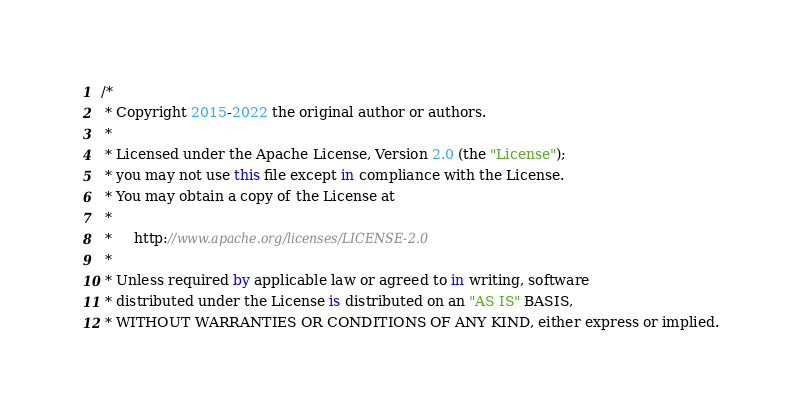Convert code to text. <code><loc_0><loc_0><loc_500><loc_500><_Kotlin_>/*
 * Copyright 2015-2022 the original author or authors.
 *
 * Licensed under the Apache License, Version 2.0 (the "License");
 * you may not use this file except in compliance with the License.
 * You may obtain a copy of the License at
 *
 *     http://www.apache.org/licenses/LICENSE-2.0
 *
 * Unless required by applicable law or agreed to in writing, software
 * distributed under the License is distributed on an "AS IS" BASIS,
 * WITHOUT WARRANTIES OR CONDITIONS OF ANY KIND, either express or implied.</code> 